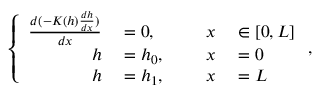<formula> <loc_0><loc_0><loc_500><loc_500>\left \{ \begin{array} { r l r l } { \frac { d ( - K ( h ) \frac { d h } { d x } ) } { d x } } & = 0 , \quad } & { x } & \in [ 0 , L ] } \\ { h } & = h _ { 0 } , } & { x } & = 0 } \\ { h } & = h _ { 1 } , } & { x } & = L } \end{array} ,</formula> 